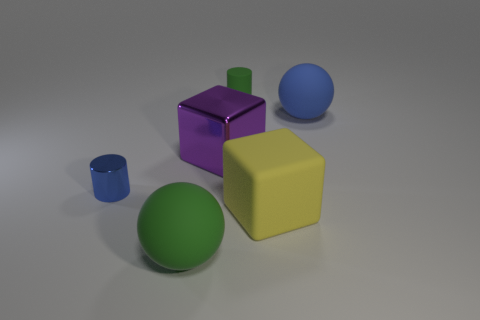Add 4 tiny blue metallic balls. How many objects exist? 10 Subtract all balls. How many objects are left? 4 Add 5 blue rubber objects. How many blue rubber objects are left? 6 Add 4 large matte cubes. How many large matte cubes exist? 5 Subtract 1 green cylinders. How many objects are left? 5 Subtract all yellow matte things. Subtract all small matte things. How many objects are left? 4 